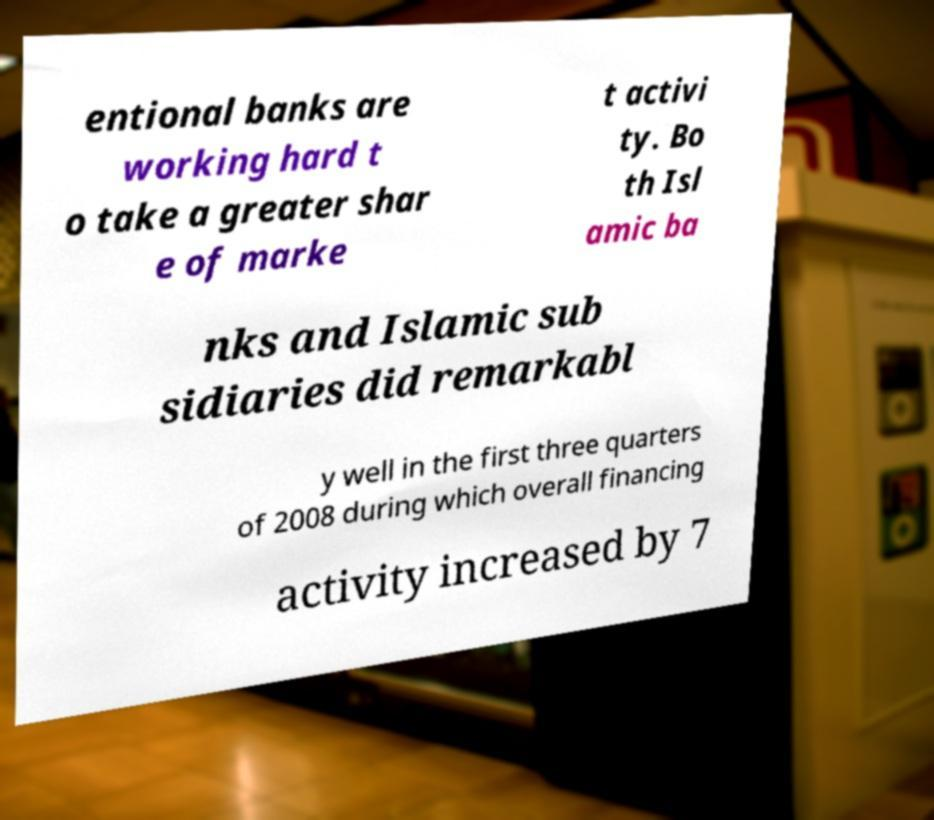Please read and relay the text visible in this image. What does it say? entional banks are working hard t o take a greater shar e of marke t activi ty. Bo th Isl amic ba nks and Islamic sub sidiaries did remarkabl y well in the first three quarters of 2008 during which overall financing activity increased by 7 